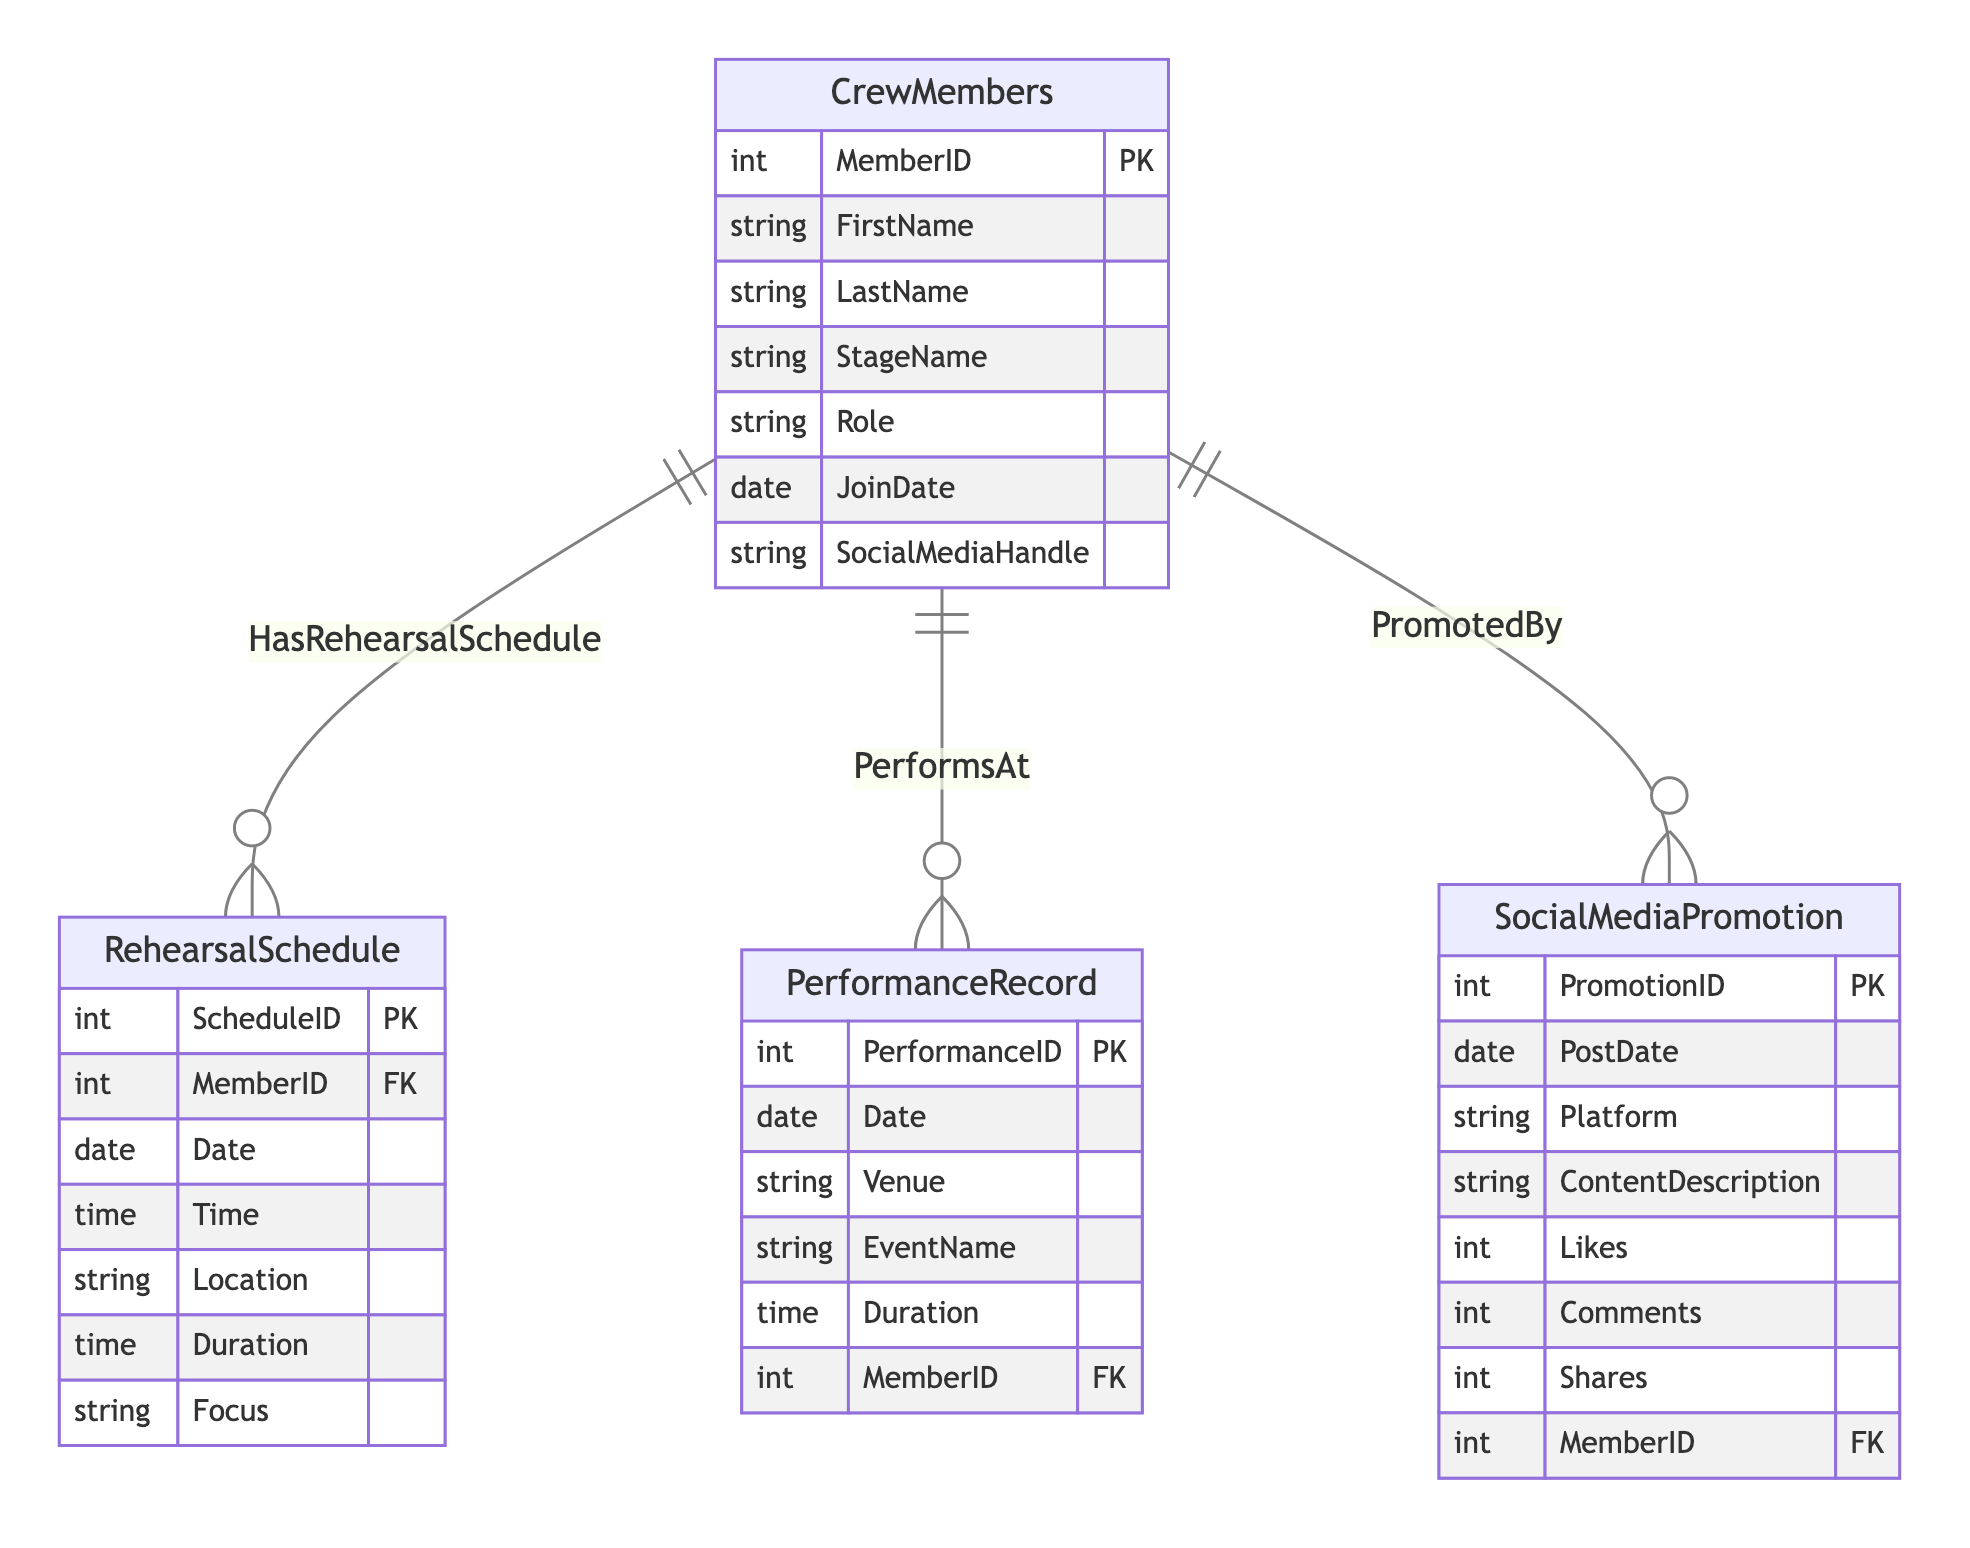What is the primary key of the CrewMembers entity? The primary key of the CrewMembers entity is the MemberID, which uniquely identifies each crew member in the database.
Answer: MemberID How many attributes are there in the PerformanceRecord entity? The PerformanceRecord entity has five attributes: PerformanceID, Date, Venue, EventName, and Duration, counting towards a total of five.
Answer: Five What type of relationship exists between CrewMembers and RehearsalSchedule? The relationship between CrewMembers and RehearsalSchedule is a one-to-many relationship, represented as 'HasRehearsalSchedule', where one crew member can have multiple rehearsal schedules.
Answer: One-to-many What is the foreign key in the SocialMediaPromotion entity? The foreign key in the SocialMediaPromotion entity is MemberID, which links each promotion to a specific crew member in the CrewMembers entity.
Answer: MemberID How many members can perform at a single PerformanceRecord? Each PerformanceRecord includes one member as indicated by the relationship 'IncludesMember', implying one performance record can only correspond to one crew member while a member can perform at many events.
Answer: One Which entity has the attribute Duration associated with both RehearsalSchedule and PerformanceRecord? The attribute Duration appears in both the RehearsalSchedule and PerformanceRecord entities, signifying that both rehearsals and performances have a specified duration.
Answer: Duration How does the SocialMediaPromotion entity relate to CrewMembers? The SocialMediaPromotion entity has a one-to-many relationship with CrewMembers, which is established through the foreign key MemberID indicating that one crew member can promote multiple posts on social media.
Answer: One-to-many What information does the EngagementMetrics attribute contain in the SocialMediaPromotion entity? The EngagementMetrics attribute contains three types of information: Likes, Comments, and Shares, which quantify the engagement on the social media post.
Answer: Likes, Comments, Shares 